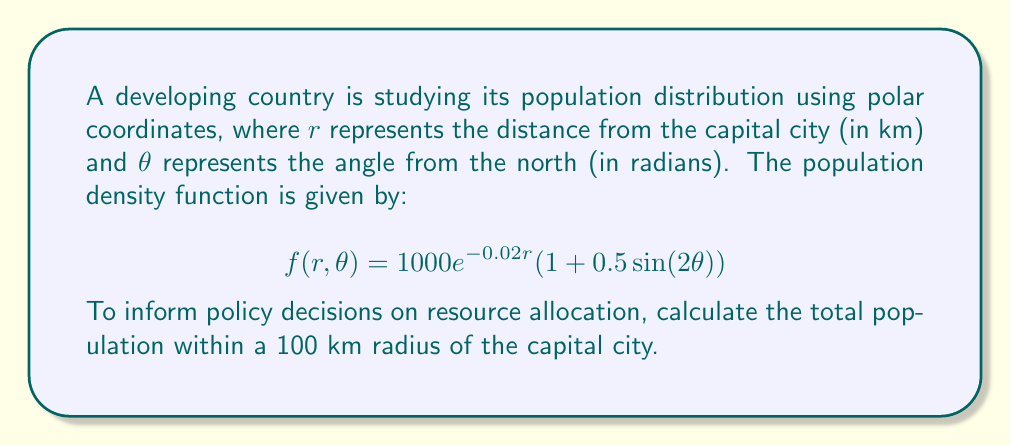Help me with this question. To solve this problem, we need to integrate the population density function over the given region. In polar coordinates, this involves a double integral:

$$\text{Total Population} = \int_{0}^{2\pi}\int_{0}^{100} f(r,\theta) \, r \, dr \, d\theta$$

Let's break this down step-by-step:

1) First, we integrate with respect to $r$:

   $$\int_{0}^{100} 1000e^{-0.02r}r \, dr = 1000 \int_{0}^{100} re^{-0.02r} \, dr$$

   This integral can be solved using integration by parts. Let $u = r$ and $dv = e^{-0.02r} \, dr$. Then $du = dr$ and $v = -50e^{-0.02r}$.

   $$= 1000 \left[-50re^{-0.02r} \bigg|_{0}^{100} + 50\int_{0}^{100} e^{-0.02r} \, dr\right]$$
   $$= 1000 \left[-50(100)e^{-2} + 0 - 50(-50e^{-0.02r} \bigg|_{0}^{100})\right]$$
   $$= 1000 \left[-5000e^{-2} + 2500 - 2500e^{-2}\right]$$
   $$= 1000(2500 - 7500e^{-2})$$

2) Now, we integrate with respect to $\theta$:

   $$\int_{0}^{2\pi} (1000(2500 - 7500e^{-2}))(1 + 0.5\sin(2\theta)) \, d\theta$$
   $$= 1000(2500 - 7500e^{-2}) \left[\theta + 0.25\sin(2\theta) \bigg|_{0}^{2\pi}\right]$$
   $$= 1000(2500 - 7500e^{-2})(2\pi)$$

3) Simplify:
   $$= 2000\pi(2500 - 7500e^{-2})$$
   $$\approx 15,079,644.737$$

Therefore, the total population within a 100 km radius of the capital city is approximately 15,079,645 people.
Answer: 15,079,645 people (rounded to the nearest whole number) 